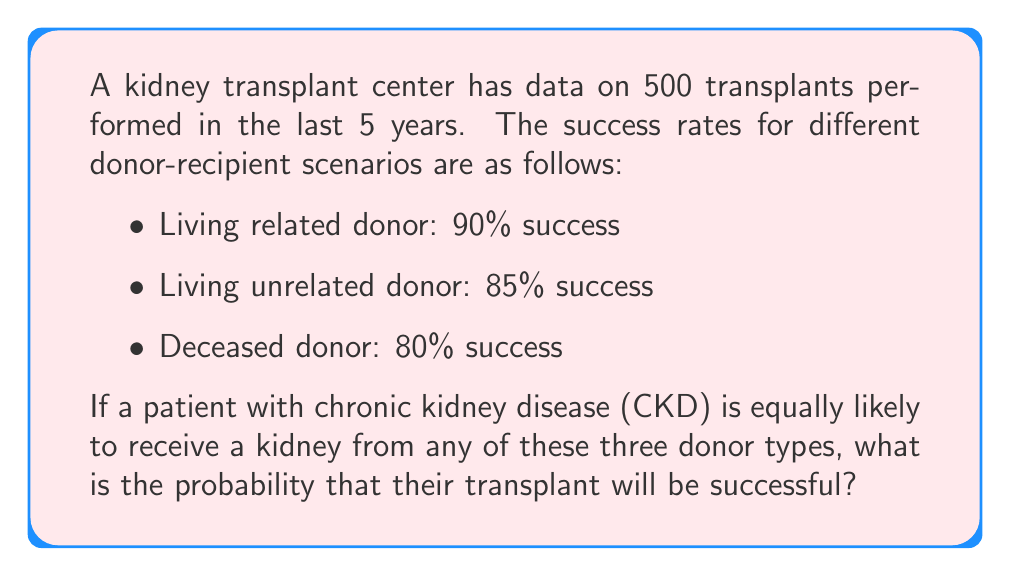What is the answer to this math problem? Let's approach this step-by-step:

1) First, we need to understand that this is a problem of total probability. The probability of success depends on the type of donor, and we need to consider all possible scenarios.

2) Let's define our events:
   S: Successful transplant
   LR: Living related donor
   LU: Living unrelated donor
   D: Deceased donor

3) We're given the following probabilities:
   $P(S|LR) = 0.90$
   $P(S|LU) = 0.85$
   $P(S|D) = 0.80$

4) We're told that the patient is equally likely to receive a kidney from any of these three donor types. This means:
   $P(LR) = P(LU) = P(D) = \frac{1}{3}$

5) We can use the law of total probability:
   $$P(S) = P(S|LR) \cdot P(LR) + P(S|LU) \cdot P(LU) + P(S|D) \cdot P(D)$$

6) Substituting our known values:
   $$P(S) = 0.90 \cdot \frac{1}{3} + 0.85 \cdot \frac{1}{3} + 0.80 \cdot \frac{1}{3}$$

7) Simplifying:
   $$P(S) = \frac{0.90 + 0.85 + 0.80}{3} = \frac{2.55}{3} = 0.85$$

Thus, the probability that the transplant will be successful is 0.85 or 85%.
Answer: 0.85 